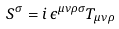Convert formula to latex. <formula><loc_0><loc_0><loc_500><loc_500>S ^ { \sigma } = i \, \epsilon ^ { \mu \nu \rho \sigma } T _ { \mu \nu \rho }</formula> 